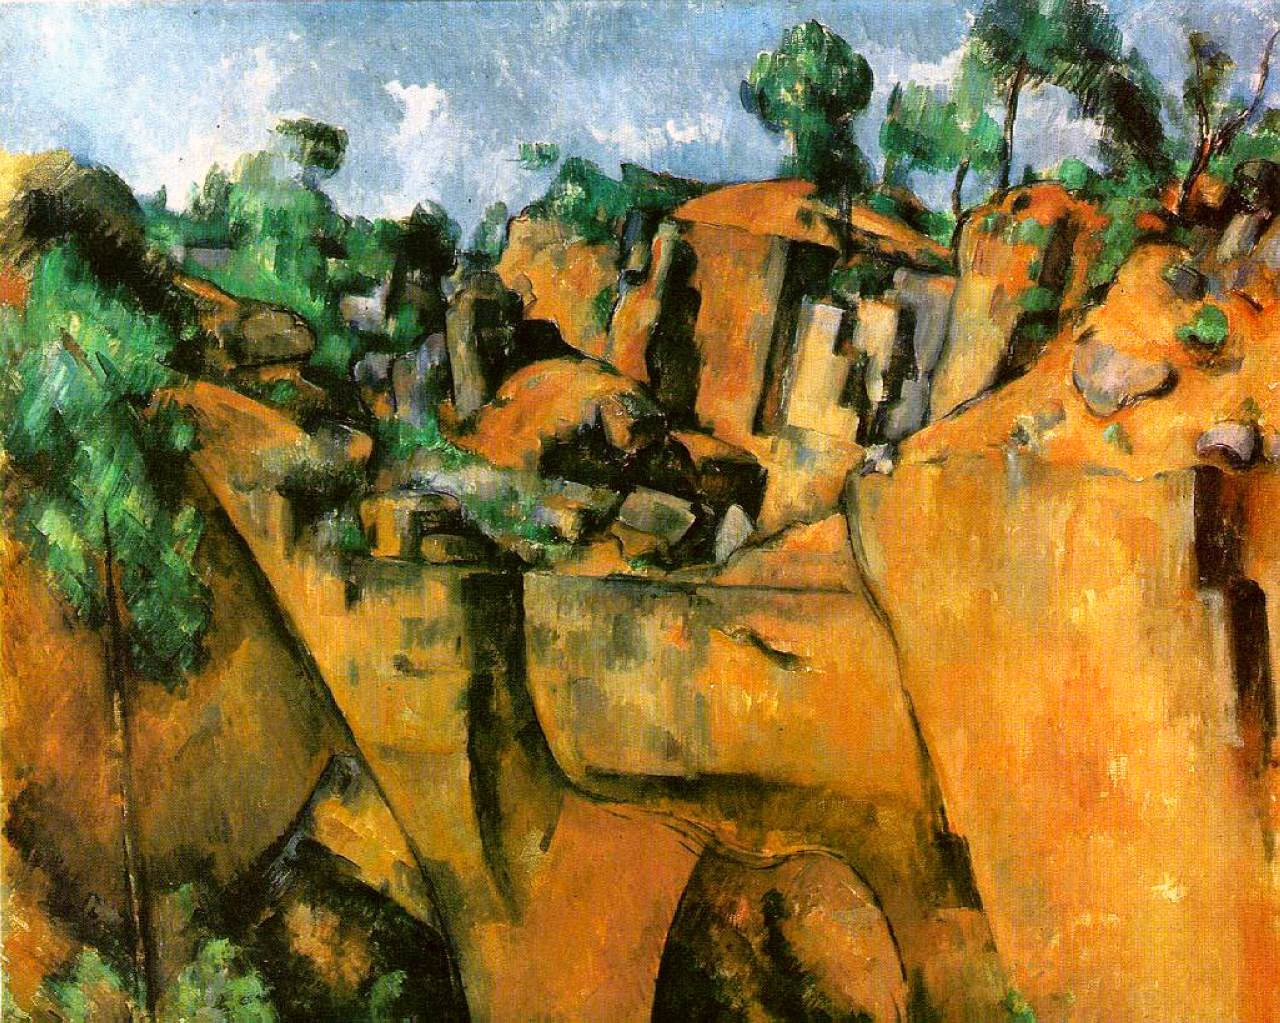How might the location depicted influence the style of this painting? This depiction of a rugged, densely vegetated landscape suggests that the artist may have been inspired by a particular locale that features these characteristics. The disrupted, almost tumultuous layout of the scene, with houses embedded in rocky outcrops, could reflect the chaotic beauty of nature, influencing the artist to adopt a vibrant, kinetic style that captures both the wildness and idyllic aspects of such a landscape. What could have been the artist's intention behind this composition? The artist's composition, merging nature and man-made structures seamlessly, might be conveying a philosophical or aesthetic statement about the symbiotic relationship between humans and nature. It suggests a narrative where human life is intimately and irrevocably intertwined with the natural environment, possibly urging viewers to reflect on their own relationship with the natural world. 